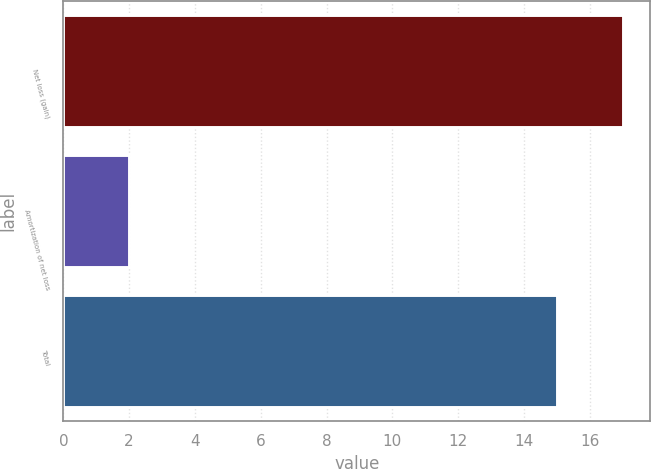Convert chart. <chart><loc_0><loc_0><loc_500><loc_500><bar_chart><fcel>Net loss (gain)<fcel>Amortization of net loss<fcel>Total<nl><fcel>17<fcel>2<fcel>15<nl></chart> 